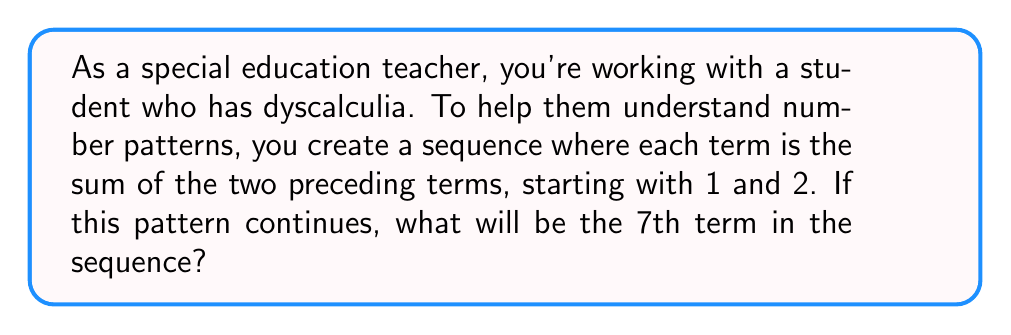Teach me how to tackle this problem. Let's approach this step-by-step:

1. First, let's write out the sequence based on the given rule:
   - The first term is 1
   - The second term is 2
   - Each subsequent term is the sum of the two preceding terms

2. Let's calculate the first few terms:
   - 1st term: $1$
   - 2nd term: $2$
   - 3rd term: $1 + 2 = 3$
   - 4th term: $2 + 3 = 5$
   - 5th term: $3 + 5 = 8$
   - 6th term: $5 + 8 = 13$

3. Now, to find the 7th term, we add the 5th and 6th terms:
   $$8 + 13 = 21$$

4. Therefore, the 7th term in the sequence is 21.

This sequence is known as the Fibonacci sequence, which is a great tool for teaching pattern recognition to students with learning disabilities. It provides a clear, predictable pattern that can be visualized and calculated step-by-step.
Answer: 21 